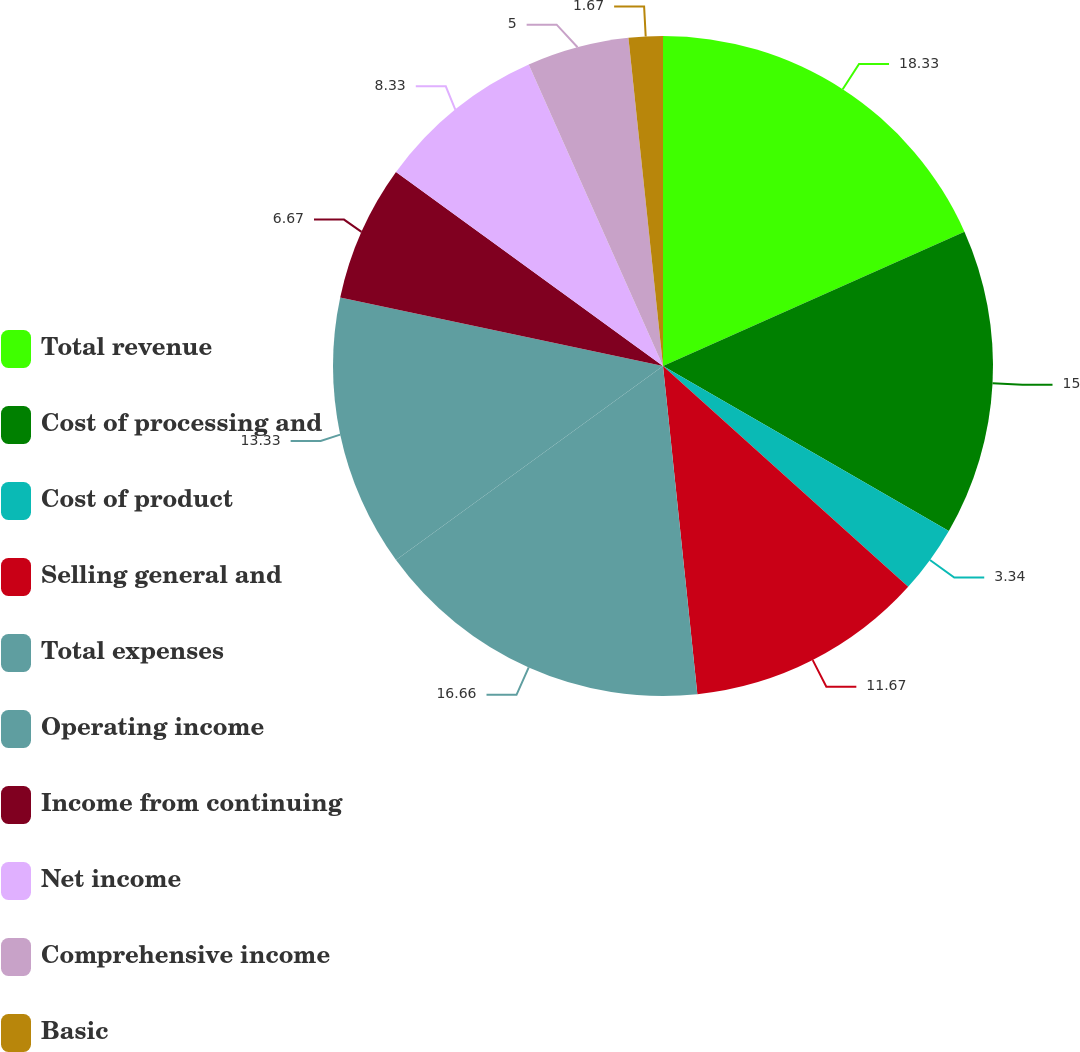<chart> <loc_0><loc_0><loc_500><loc_500><pie_chart><fcel>Total revenue<fcel>Cost of processing and<fcel>Cost of product<fcel>Selling general and<fcel>Total expenses<fcel>Operating income<fcel>Income from continuing<fcel>Net income<fcel>Comprehensive income<fcel>Basic<nl><fcel>18.33%<fcel>15.0%<fcel>3.34%<fcel>11.67%<fcel>16.66%<fcel>13.33%<fcel>6.67%<fcel>8.33%<fcel>5.0%<fcel>1.67%<nl></chart> 